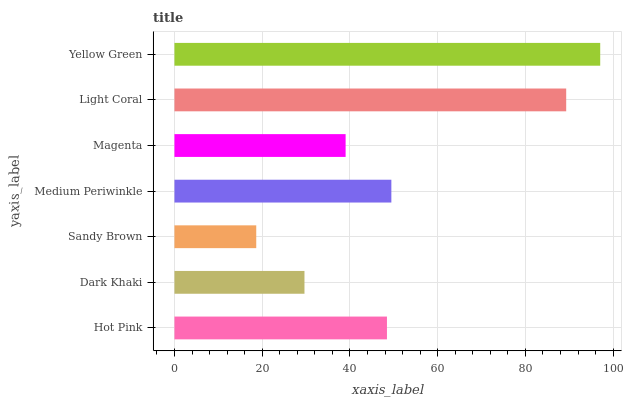Is Sandy Brown the minimum?
Answer yes or no. Yes. Is Yellow Green the maximum?
Answer yes or no. Yes. Is Dark Khaki the minimum?
Answer yes or no. No. Is Dark Khaki the maximum?
Answer yes or no. No. Is Hot Pink greater than Dark Khaki?
Answer yes or no. Yes. Is Dark Khaki less than Hot Pink?
Answer yes or no. Yes. Is Dark Khaki greater than Hot Pink?
Answer yes or no. No. Is Hot Pink less than Dark Khaki?
Answer yes or no. No. Is Hot Pink the high median?
Answer yes or no. Yes. Is Hot Pink the low median?
Answer yes or no. Yes. Is Magenta the high median?
Answer yes or no. No. Is Sandy Brown the low median?
Answer yes or no. No. 